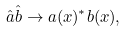Convert formula to latex. <formula><loc_0><loc_0><loc_500><loc_500>\hat { a } \hat { b } \rightarrow a ( x ) ^ { * } b ( x ) ,</formula> 